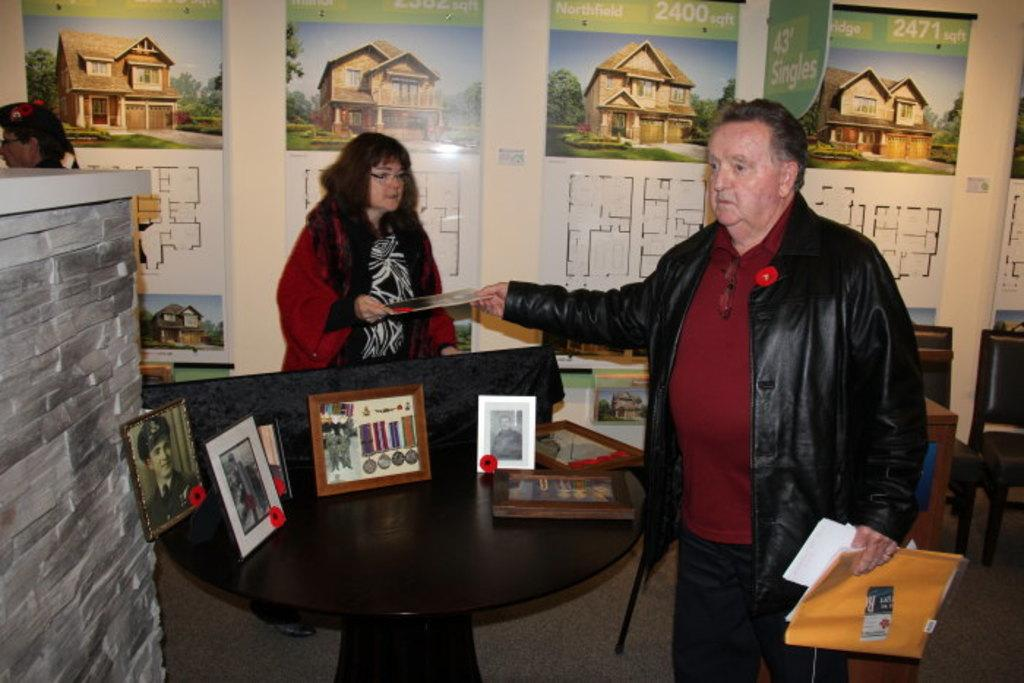Who is the main subject in the image? There is a man in the image. What is the man doing in the image? The man is handing over a card. Who else is present in the image? There is a woman in the image. What is the woman doing in the image? The woman is standing at a table. What objects can be seen on the table? There are photo frames on the table. What type of lamp is visible on the table in the image? There is no lamp present on the table in the image. What is the size of the sun in the image? The image does not depict the sun, so its size cannot be determined. 